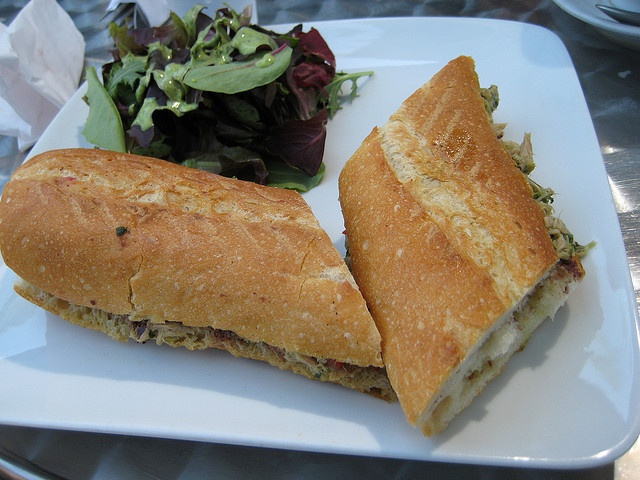Describe the objects in this image and their specific colors. I can see bowl in blue, lightblue, olive, tan, and gray tones, sandwich in blue, olive, gray, and tan tones, sandwich in blue, olive, tan, and gray tones, bowl in blue, gray, and black tones, and spoon in blue, black, and navy tones in this image. 